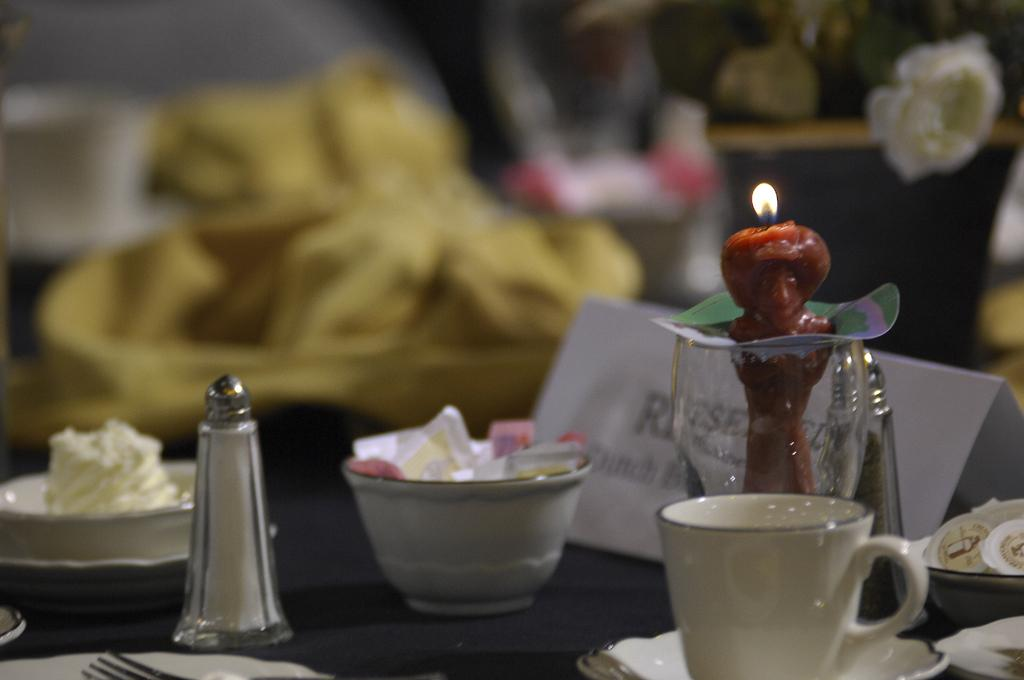What type of furniture is present in the image? There is a table in the image. What object can be seen on top of the table? There is a sprinkler on the table. What else is on the table besides the sprinkler? There is a bowl of salt packets, a cup and saucer, a candle, a plate with food, and a napkin on the table. What type of operation is being performed on the zebra in the image? There is no zebra present in the image, and therefore no operation is being performed. 